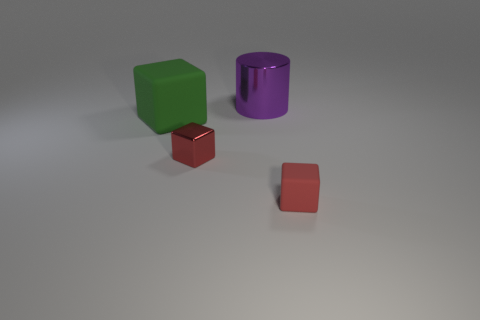Add 3 green cubes. How many objects exist? 7 Subtract all cylinders. How many objects are left? 3 Add 2 big green objects. How many big green objects are left? 3 Add 1 large yellow metallic cubes. How many large yellow metallic cubes exist? 1 Subtract 0 yellow cylinders. How many objects are left? 4 Subtract all big purple objects. Subtract all large green rubber blocks. How many objects are left? 2 